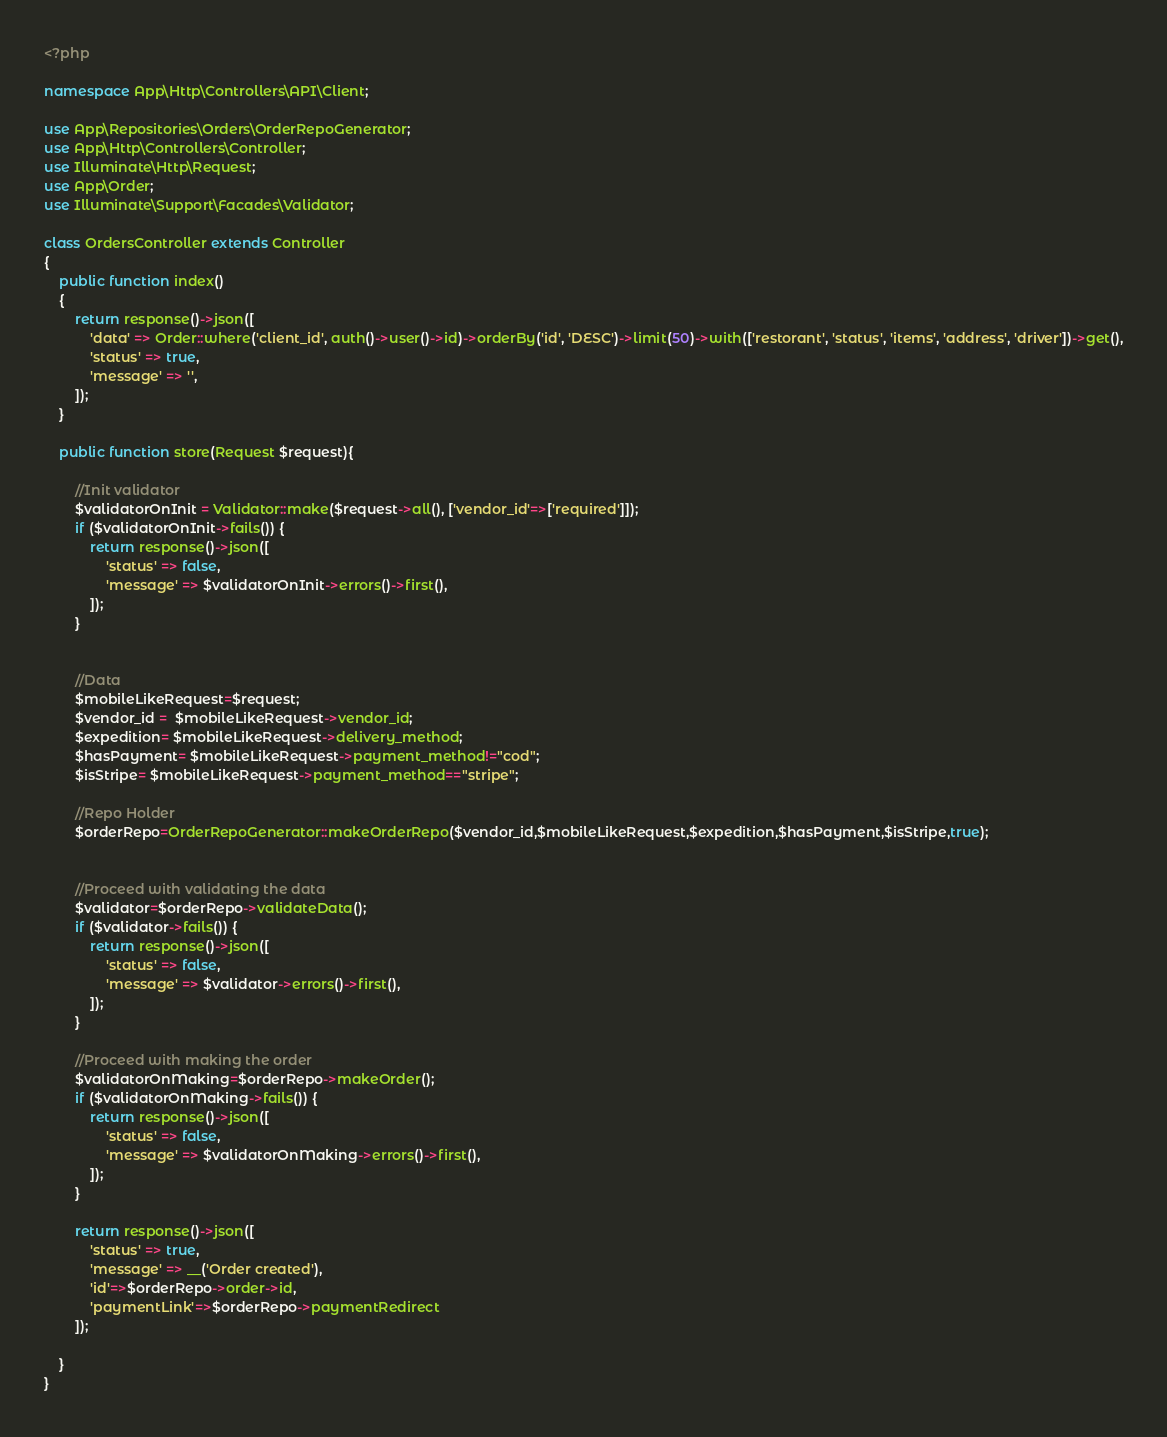<code> <loc_0><loc_0><loc_500><loc_500><_PHP_><?php

namespace App\Http\Controllers\API\Client;

use App\Repositories\Orders\OrderRepoGenerator;
use App\Http\Controllers\Controller;
use Illuminate\Http\Request;
use App\Order;
use Illuminate\Support\Facades\Validator;

class OrdersController extends Controller
{
    public function index()
    {
        return response()->json([
            'data' => Order::where('client_id', auth()->user()->id)->orderBy('id', 'DESC')->limit(50)->with(['restorant', 'status', 'items', 'address', 'driver'])->get(),
            'status' => true,
            'message' => '',
        ]);
    }

    public function store(Request $request){
 
        //Init validator
        $validatorOnInit = Validator::make($request->all(), ['vendor_id'=>['required']]);
        if ($validatorOnInit->fails()) {
            return response()->json([
                'status' => false,
                'message' => $validatorOnInit->errors()->first(),
            ]);
        }


        //Data
        $mobileLikeRequest=$request;
        $vendor_id =  $mobileLikeRequest->vendor_id;
        $expedition= $mobileLikeRequest->delivery_method;
        $hasPayment= $mobileLikeRequest->payment_method!="cod";
        $isStripe= $mobileLikeRequest->payment_method=="stripe";

        //Repo Holder
        $orderRepo=OrderRepoGenerator::makeOrderRepo($vendor_id,$mobileLikeRequest,$expedition,$hasPayment,$isStripe,true);
    
        
        //Proceed with validating the data
        $validator=$orderRepo->validateData();
        if ($validator->fails()) { 
            return response()->json([
                'status' => false,
                'message' => $validator->errors()->first(),
            ]);
        }

        //Proceed with making the order
        $validatorOnMaking=$orderRepo->makeOrder();
        if ($validatorOnMaking->fails()) { 
            return response()->json([
                'status' => false,
                'message' => $validatorOnMaking->errors()->first(),
            ]);
        }

        return response()->json([
            'status' => true,
            'message' => __('Order created'),
            'id'=>$orderRepo->order->id,
            'paymentLink'=>$orderRepo->paymentRedirect
        ]);
         
    }
}
</code> 